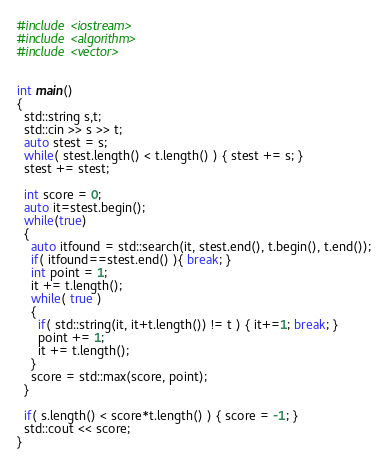Convert code to text. <code><loc_0><loc_0><loc_500><loc_500><_C++_>
#include <iostream>
#include <algorithm>
#include <vector>


int main()
{
  std::string s,t;
  std::cin >> s >> t;
  auto stest = s;
  while( stest.length() < t.length() ) { stest += s; }
  stest += stest;

  int score = 0;
  auto it=stest.begin();
  while(true)
  {
    auto itfound = std::search(it, stest.end(), t.begin(), t.end());
    if( itfound==stest.end() ){ break; }
    int point = 1;
    it += t.length();
    while( true )
    {
      if( std::string(it, it+t.length()) != t ) { it+=1; break; }
      point += 1;
      it += t.length();
    }
    score = std::max(score, point);
  }

  if( s.length() < score*t.length() ) { score = -1; }
  std::cout << score;
}</code> 